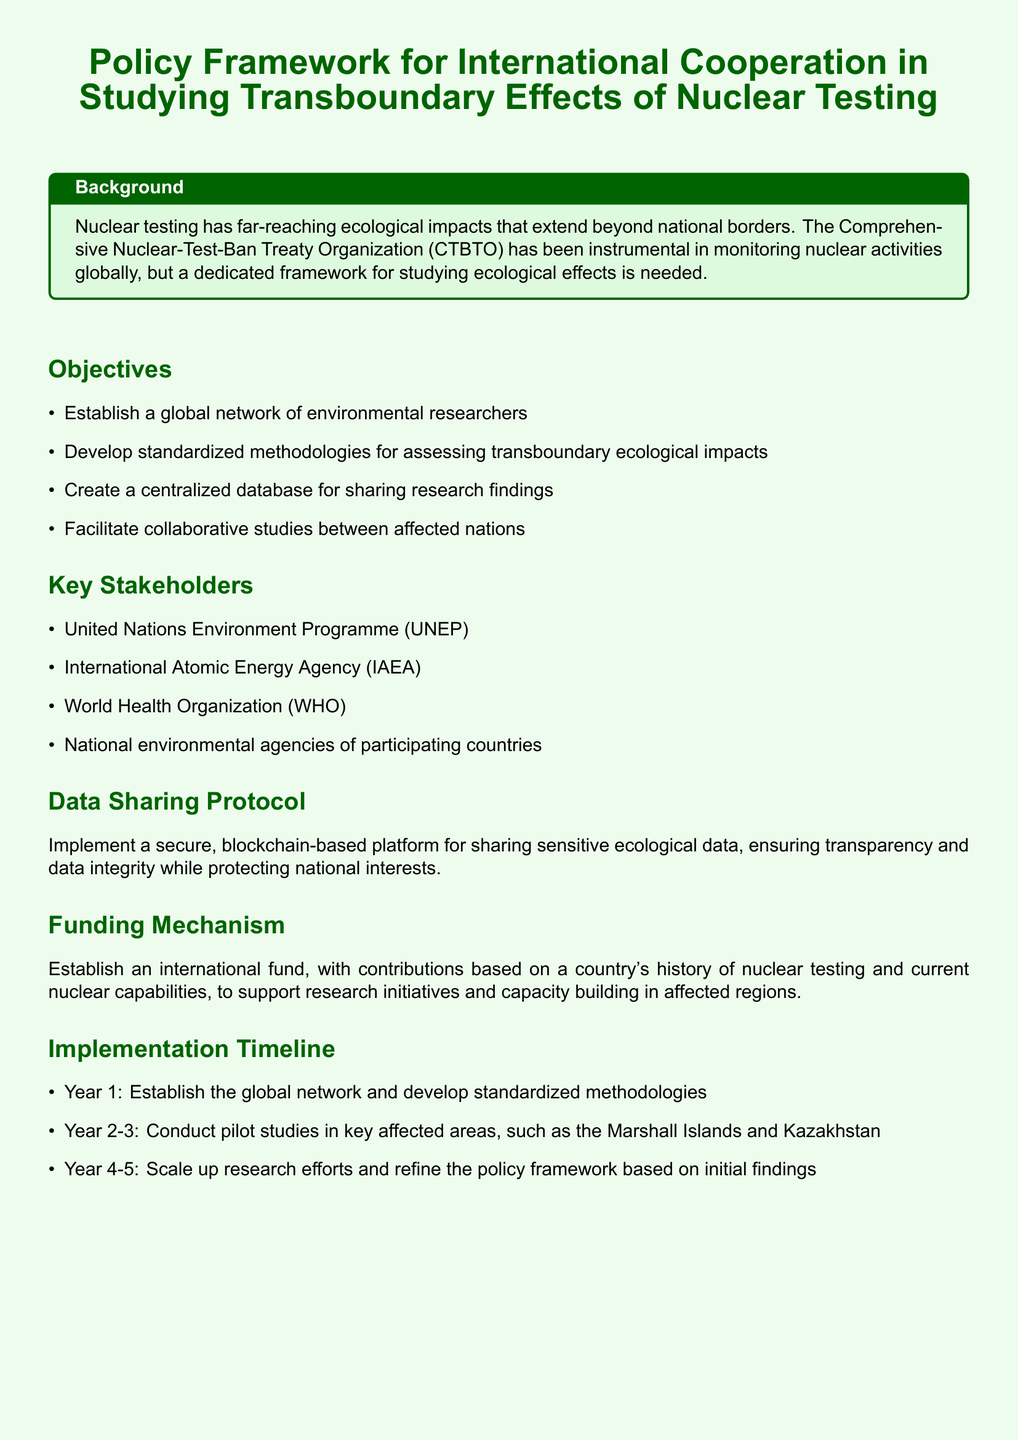What is the title of the document? The title summarizes the focus of the document, which is significant for identification.
Answer: Policy Framework for International Cooperation in Studying Transboundary Effects of Nuclear Testing Who are the key stakeholders mentioned? The stakeholders are listed in a section dedicated to identifying the relevant parties involved in the policy.
Answer: United Nations Environment Programme (UNEP), International Atomic Energy Agency (IAEA), World Health Organization (WHO), National environmental agencies of participating countries What is the purpose of the international fund? The funding mechanism section outlines the rationale for establishing the fund.
Answer: To support research initiatives and capacity building in affected regions How long is the implementation timeline? This refers to the duration over which the key activities outlined will take place.
Answer: 5 years What technology is proposed for data sharing? The document specifies a particular type of technology to ensure secure data sharing.
Answer: Blockchain-based platform Which areas are identified for pilot studies? The implementation section highlights specific regions recognized for initial research efforts.
Answer: Marshall Islands and Kazakhstan What is the first objective of the document? The objectives section succinctly lays out the main goals of the initiative.
Answer: Establish a global network of environmental researchers In which year will the global network be established? The timeline provides specific years for the various objectives listed in the document.
Answer: Year 1 What is the color used for the section titles? The color scheme is referred to in the formatting section, indicating the document's design choices.
Answer: Dark green 